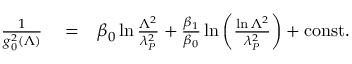Convert formula to latex. <formula><loc_0><loc_0><loc_500><loc_500>\begin{array} { r l r } { { \frac { 1 } { g _ { 0 } ^ { 2 } ( \Lambda ) } } } & = } & { \beta _ { 0 } \ln { \frac { \Lambda ^ { 2 } } { \lambda _ { P } ^ { 2 } } } + { \frac { \beta _ { 1 } } { \beta _ { 0 } } } \ln \left ( { \frac { \ln \Lambda ^ { 2 } } { \lambda _ { P } ^ { 2 } } } \right ) + c o n s t . } \end{array}</formula> 